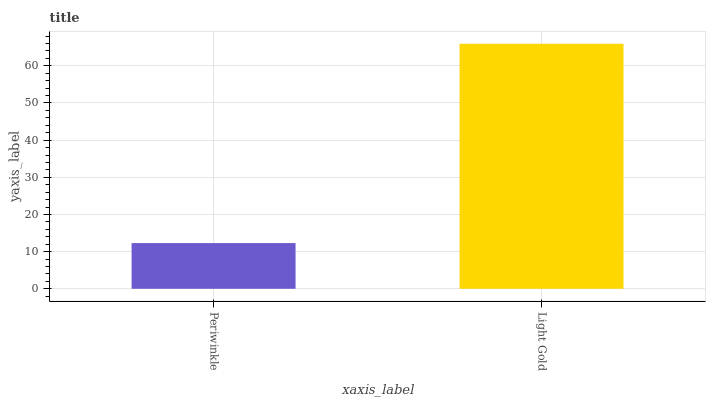Is Periwinkle the minimum?
Answer yes or no. Yes. Is Light Gold the maximum?
Answer yes or no. Yes. Is Light Gold the minimum?
Answer yes or no. No. Is Light Gold greater than Periwinkle?
Answer yes or no. Yes. Is Periwinkle less than Light Gold?
Answer yes or no. Yes. Is Periwinkle greater than Light Gold?
Answer yes or no. No. Is Light Gold less than Periwinkle?
Answer yes or no. No. Is Light Gold the high median?
Answer yes or no. Yes. Is Periwinkle the low median?
Answer yes or no. Yes. Is Periwinkle the high median?
Answer yes or no. No. Is Light Gold the low median?
Answer yes or no. No. 